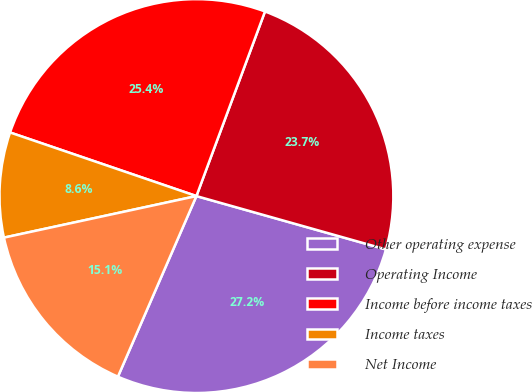Convert chart to OTSL. <chart><loc_0><loc_0><loc_500><loc_500><pie_chart><fcel>Other operating expense<fcel>Operating Income<fcel>Income before income taxes<fcel>Income taxes<fcel>Net Income<nl><fcel>27.16%<fcel>23.71%<fcel>25.43%<fcel>8.62%<fcel>15.09%<nl></chart> 